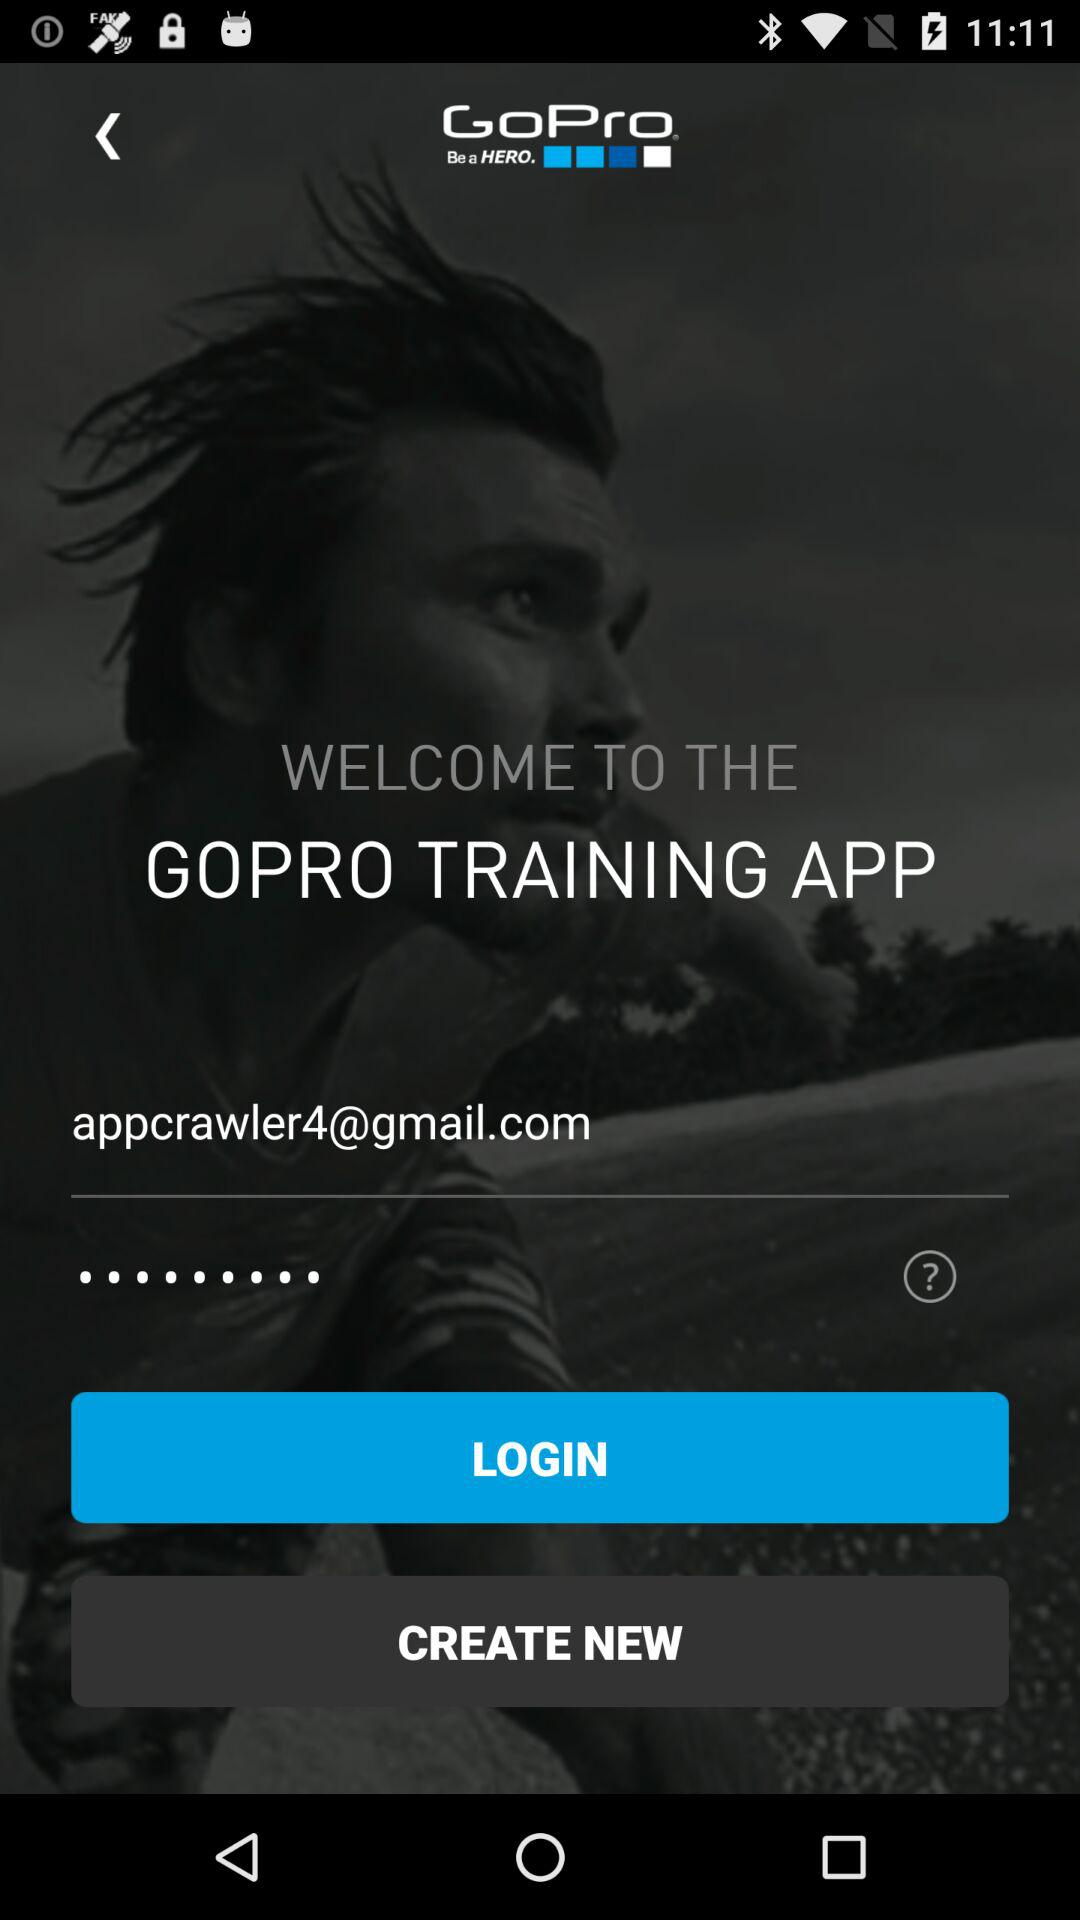How many text inputs are on the screen?
Answer the question using a single word or phrase. 2 